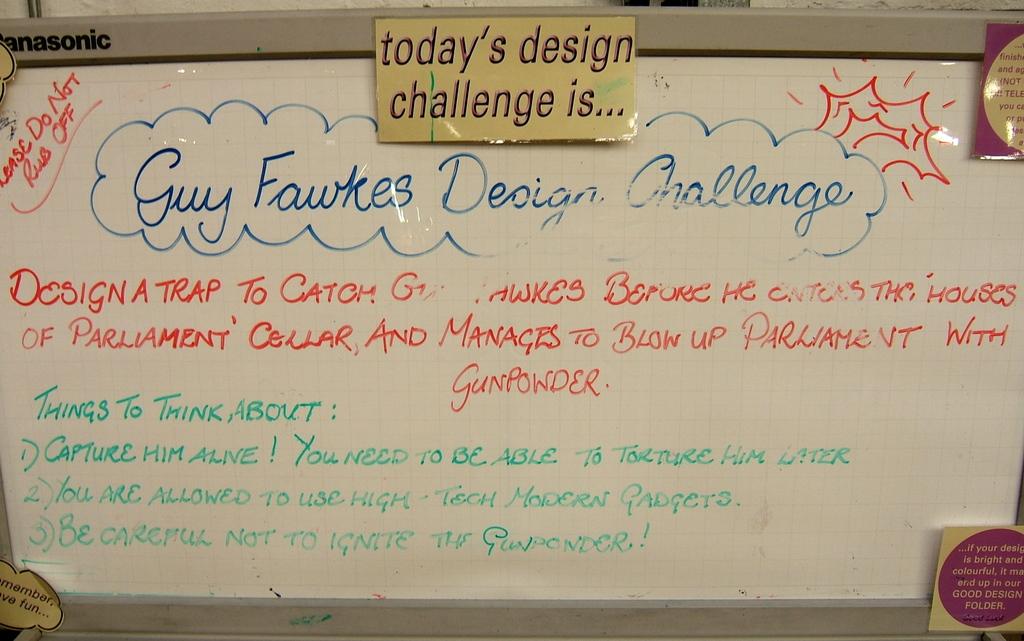What does the whiteboard talk about?
Keep it short and to the point. Guy fawkes design challenge. What things does the whiteboard tell me to think about?
Your answer should be very brief. Capture him alive. 